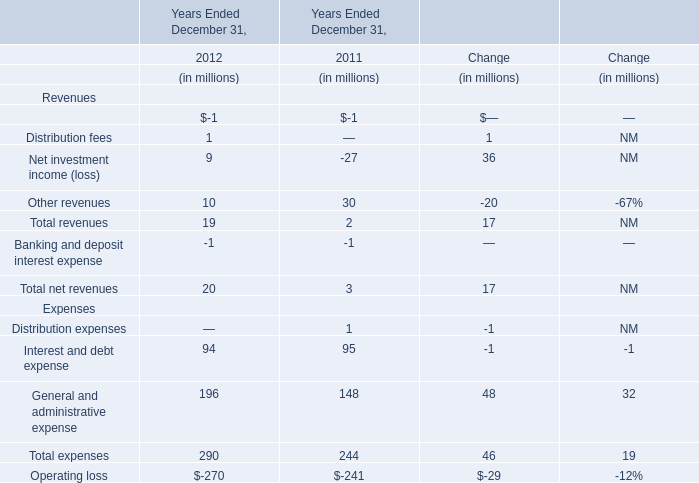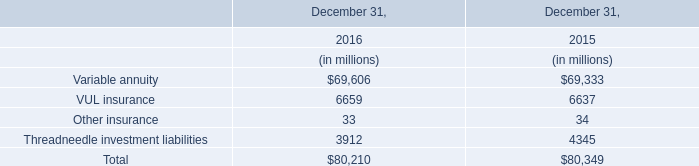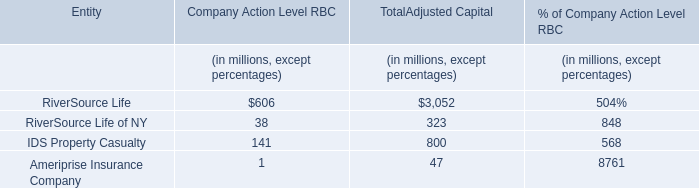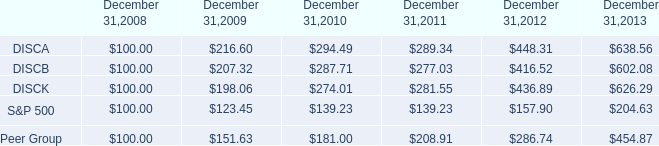what was the five year average uncompounded annual return for the s&p 500? 
Computations: ((204.63 - 100) / (2013 - 2008))
Answer: 20.926. 